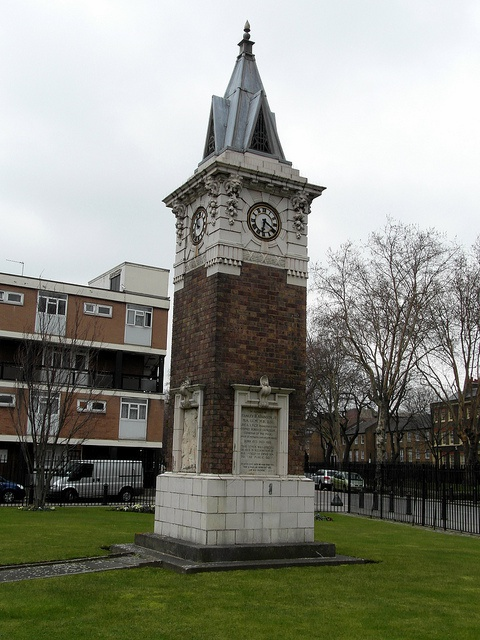Describe the objects in this image and their specific colors. I can see truck in white, black, gray, and darkgray tones, clock in white, black, and gray tones, car in white, black, gray, and darkgreen tones, car in white, black, navy, gray, and darkblue tones, and car in white, black, gray, darkgray, and lightgray tones in this image. 